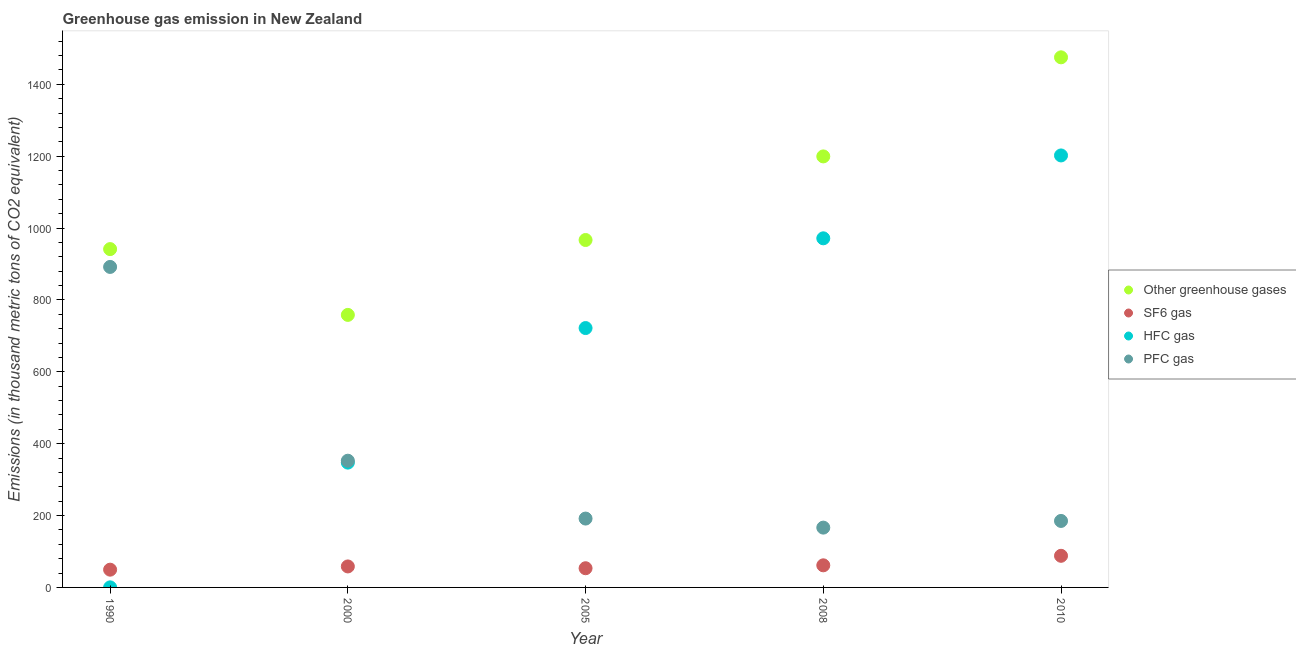How many different coloured dotlines are there?
Provide a succinct answer. 4. What is the emission of hfc gas in 2000?
Keep it short and to the point. 347.3. Across all years, what is the maximum emission of hfc gas?
Keep it short and to the point. 1202. Across all years, what is the minimum emission of hfc gas?
Provide a short and direct response. 0.2. What is the total emission of pfc gas in the graph?
Your response must be concise. 1787.4. What is the difference between the emission of sf6 gas in 2000 and that in 2008?
Offer a terse response. -3.1. What is the difference between the emission of hfc gas in 2010 and the emission of greenhouse gases in 2008?
Your answer should be very brief. 2.7. What is the average emission of sf6 gas per year?
Offer a terse response. 62.14. In the year 2005, what is the difference between the emission of greenhouse gases and emission of hfc gas?
Ensure brevity in your answer.  245. What is the ratio of the emission of pfc gas in 2000 to that in 2008?
Provide a succinct answer. 2.12. Is the emission of greenhouse gases in 2008 less than that in 2010?
Provide a short and direct response. Yes. Is the difference between the emission of greenhouse gases in 2008 and 2010 greater than the difference between the emission of pfc gas in 2008 and 2010?
Give a very brief answer. No. What is the difference between the highest and the lowest emission of pfc gas?
Offer a very short reply. 725.4. Is it the case that in every year, the sum of the emission of pfc gas and emission of sf6 gas is greater than the sum of emission of greenhouse gases and emission of hfc gas?
Provide a succinct answer. No. Is the emission of hfc gas strictly less than the emission of greenhouse gases over the years?
Give a very brief answer. Yes. How many years are there in the graph?
Give a very brief answer. 5. What is the difference between two consecutive major ticks on the Y-axis?
Provide a succinct answer. 200. Does the graph contain grids?
Keep it short and to the point. No. How are the legend labels stacked?
Ensure brevity in your answer.  Vertical. What is the title of the graph?
Give a very brief answer. Greenhouse gas emission in New Zealand. Does "Secondary general" appear as one of the legend labels in the graph?
Make the answer very short. No. What is the label or title of the Y-axis?
Offer a terse response. Emissions (in thousand metric tons of CO2 equivalent). What is the Emissions (in thousand metric tons of CO2 equivalent) of Other greenhouse gases in 1990?
Provide a succinct answer. 941.4. What is the Emissions (in thousand metric tons of CO2 equivalent) of SF6 gas in 1990?
Give a very brief answer. 49.4. What is the Emissions (in thousand metric tons of CO2 equivalent) of PFC gas in 1990?
Provide a succinct answer. 891.8. What is the Emissions (in thousand metric tons of CO2 equivalent) in Other greenhouse gases in 2000?
Your answer should be compact. 758.3. What is the Emissions (in thousand metric tons of CO2 equivalent) in SF6 gas in 2000?
Give a very brief answer. 58.4. What is the Emissions (in thousand metric tons of CO2 equivalent) of HFC gas in 2000?
Ensure brevity in your answer.  347.3. What is the Emissions (in thousand metric tons of CO2 equivalent) in PFC gas in 2000?
Ensure brevity in your answer.  352.6. What is the Emissions (in thousand metric tons of CO2 equivalent) in Other greenhouse gases in 2005?
Your answer should be very brief. 966.7. What is the Emissions (in thousand metric tons of CO2 equivalent) of SF6 gas in 2005?
Offer a terse response. 53.4. What is the Emissions (in thousand metric tons of CO2 equivalent) in HFC gas in 2005?
Provide a succinct answer. 721.7. What is the Emissions (in thousand metric tons of CO2 equivalent) of PFC gas in 2005?
Offer a very short reply. 191.6. What is the Emissions (in thousand metric tons of CO2 equivalent) in Other greenhouse gases in 2008?
Make the answer very short. 1199.3. What is the Emissions (in thousand metric tons of CO2 equivalent) of SF6 gas in 2008?
Offer a terse response. 61.5. What is the Emissions (in thousand metric tons of CO2 equivalent) of HFC gas in 2008?
Provide a short and direct response. 971.4. What is the Emissions (in thousand metric tons of CO2 equivalent) in PFC gas in 2008?
Ensure brevity in your answer.  166.4. What is the Emissions (in thousand metric tons of CO2 equivalent) in Other greenhouse gases in 2010?
Provide a succinct answer. 1475. What is the Emissions (in thousand metric tons of CO2 equivalent) in SF6 gas in 2010?
Give a very brief answer. 88. What is the Emissions (in thousand metric tons of CO2 equivalent) in HFC gas in 2010?
Keep it short and to the point. 1202. What is the Emissions (in thousand metric tons of CO2 equivalent) in PFC gas in 2010?
Provide a short and direct response. 185. Across all years, what is the maximum Emissions (in thousand metric tons of CO2 equivalent) of Other greenhouse gases?
Provide a short and direct response. 1475. Across all years, what is the maximum Emissions (in thousand metric tons of CO2 equivalent) of SF6 gas?
Keep it short and to the point. 88. Across all years, what is the maximum Emissions (in thousand metric tons of CO2 equivalent) of HFC gas?
Provide a succinct answer. 1202. Across all years, what is the maximum Emissions (in thousand metric tons of CO2 equivalent) of PFC gas?
Your answer should be very brief. 891.8. Across all years, what is the minimum Emissions (in thousand metric tons of CO2 equivalent) in Other greenhouse gases?
Offer a terse response. 758.3. Across all years, what is the minimum Emissions (in thousand metric tons of CO2 equivalent) of SF6 gas?
Give a very brief answer. 49.4. Across all years, what is the minimum Emissions (in thousand metric tons of CO2 equivalent) in PFC gas?
Offer a very short reply. 166.4. What is the total Emissions (in thousand metric tons of CO2 equivalent) in Other greenhouse gases in the graph?
Your response must be concise. 5340.7. What is the total Emissions (in thousand metric tons of CO2 equivalent) in SF6 gas in the graph?
Your answer should be compact. 310.7. What is the total Emissions (in thousand metric tons of CO2 equivalent) of HFC gas in the graph?
Offer a very short reply. 3242.6. What is the total Emissions (in thousand metric tons of CO2 equivalent) of PFC gas in the graph?
Provide a succinct answer. 1787.4. What is the difference between the Emissions (in thousand metric tons of CO2 equivalent) in Other greenhouse gases in 1990 and that in 2000?
Your response must be concise. 183.1. What is the difference between the Emissions (in thousand metric tons of CO2 equivalent) of SF6 gas in 1990 and that in 2000?
Ensure brevity in your answer.  -9. What is the difference between the Emissions (in thousand metric tons of CO2 equivalent) in HFC gas in 1990 and that in 2000?
Your answer should be compact. -347.1. What is the difference between the Emissions (in thousand metric tons of CO2 equivalent) of PFC gas in 1990 and that in 2000?
Make the answer very short. 539.2. What is the difference between the Emissions (in thousand metric tons of CO2 equivalent) in Other greenhouse gases in 1990 and that in 2005?
Give a very brief answer. -25.3. What is the difference between the Emissions (in thousand metric tons of CO2 equivalent) of HFC gas in 1990 and that in 2005?
Offer a very short reply. -721.5. What is the difference between the Emissions (in thousand metric tons of CO2 equivalent) of PFC gas in 1990 and that in 2005?
Give a very brief answer. 700.2. What is the difference between the Emissions (in thousand metric tons of CO2 equivalent) of Other greenhouse gases in 1990 and that in 2008?
Give a very brief answer. -257.9. What is the difference between the Emissions (in thousand metric tons of CO2 equivalent) in SF6 gas in 1990 and that in 2008?
Ensure brevity in your answer.  -12.1. What is the difference between the Emissions (in thousand metric tons of CO2 equivalent) of HFC gas in 1990 and that in 2008?
Provide a succinct answer. -971.2. What is the difference between the Emissions (in thousand metric tons of CO2 equivalent) of PFC gas in 1990 and that in 2008?
Give a very brief answer. 725.4. What is the difference between the Emissions (in thousand metric tons of CO2 equivalent) in Other greenhouse gases in 1990 and that in 2010?
Provide a short and direct response. -533.6. What is the difference between the Emissions (in thousand metric tons of CO2 equivalent) in SF6 gas in 1990 and that in 2010?
Your answer should be compact. -38.6. What is the difference between the Emissions (in thousand metric tons of CO2 equivalent) in HFC gas in 1990 and that in 2010?
Provide a short and direct response. -1201.8. What is the difference between the Emissions (in thousand metric tons of CO2 equivalent) in PFC gas in 1990 and that in 2010?
Keep it short and to the point. 706.8. What is the difference between the Emissions (in thousand metric tons of CO2 equivalent) of Other greenhouse gases in 2000 and that in 2005?
Offer a very short reply. -208.4. What is the difference between the Emissions (in thousand metric tons of CO2 equivalent) in HFC gas in 2000 and that in 2005?
Provide a short and direct response. -374.4. What is the difference between the Emissions (in thousand metric tons of CO2 equivalent) of PFC gas in 2000 and that in 2005?
Keep it short and to the point. 161. What is the difference between the Emissions (in thousand metric tons of CO2 equivalent) in Other greenhouse gases in 2000 and that in 2008?
Make the answer very short. -441. What is the difference between the Emissions (in thousand metric tons of CO2 equivalent) in HFC gas in 2000 and that in 2008?
Provide a short and direct response. -624.1. What is the difference between the Emissions (in thousand metric tons of CO2 equivalent) of PFC gas in 2000 and that in 2008?
Keep it short and to the point. 186.2. What is the difference between the Emissions (in thousand metric tons of CO2 equivalent) in Other greenhouse gases in 2000 and that in 2010?
Offer a terse response. -716.7. What is the difference between the Emissions (in thousand metric tons of CO2 equivalent) in SF6 gas in 2000 and that in 2010?
Provide a short and direct response. -29.6. What is the difference between the Emissions (in thousand metric tons of CO2 equivalent) of HFC gas in 2000 and that in 2010?
Your response must be concise. -854.7. What is the difference between the Emissions (in thousand metric tons of CO2 equivalent) in PFC gas in 2000 and that in 2010?
Provide a short and direct response. 167.6. What is the difference between the Emissions (in thousand metric tons of CO2 equivalent) of Other greenhouse gases in 2005 and that in 2008?
Make the answer very short. -232.6. What is the difference between the Emissions (in thousand metric tons of CO2 equivalent) of HFC gas in 2005 and that in 2008?
Provide a short and direct response. -249.7. What is the difference between the Emissions (in thousand metric tons of CO2 equivalent) in PFC gas in 2005 and that in 2008?
Provide a short and direct response. 25.2. What is the difference between the Emissions (in thousand metric tons of CO2 equivalent) of Other greenhouse gases in 2005 and that in 2010?
Offer a very short reply. -508.3. What is the difference between the Emissions (in thousand metric tons of CO2 equivalent) of SF6 gas in 2005 and that in 2010?
Your answer should be compact. -34.6. What is the difference between the Emissions (in thousand metric tons of CO2 equivalent) of HFC gas in 2005 and that in 2010?
Your response must be concise. -480.3. What is the difference between the Emissions (in thousand metric tons of CO2 equivalent) of Other greenhouse gases in 2008 and that in 2010?
Offer a very short reply. -275.7. What is the difference between the Emissions (in thousand metric tons of CO2 equivalent) of SF6 gas in 2008 and that in 2010?
Offer a very short reply. -26.5. What is the difference between the Emissions (in thousand metric tons of CO2 equivalent) of HFC gas in 2008 and that in 2010?
Offer a terse response. -230.6. What is the difference between the Emissions (in thousand metric tons of CO2 equivalent) in PFC gas in 2008 and that in 2010?
Give a very brief answer. -18.6. What is the difference between the Emissions (in thousand metric tons of CO2 equivalent) of Other greenhouse gases in 1990 and the Emissions (in thousand metric tons of CO2 equivalent) of SF6 gas in 2000?
Offer a terse response. 883. What is the difference between the Emissions (in thousand metric tons of CO2 equivalent) in Other greenhouse gases in 1990 and the Emissions (in thousand metric tons of CO2 equivalent) in HFC gas in 2000?
Ensure brevity in your answer.  594.1. What is the difference between the Emissions (in thousand metric tons of CO2 equivalent) in Other greenhouse gases in 1990 and the Emissions (in thousand metric tons of CO2 equivalent) in PFC gas in 2000?
Ensure brevity in your answer.  588.8. What is the difference between the Emissions (in thousand metric tons of CO2 equivalent) of SF6 gas in 1990 and the Emissions (in thousand metric tons of CO2 equivalent) of HFC gas in 2000?
Offer a very short reply. -297.9. What is the difference between the Emissions (in thousand metric tons of CO2 equivalent) in SF6 gas in 1990 and the Emissions (in thousand metric tons of CO2 equivalent) in PFC gas in 2000?
Make the answer very short. -303.2. What is the difference between the Emissions (in thousand metric tons of CO2 equivalent) in HFC gas in 1990 and the Emissions (in thousand metric tons of CO2 equivalent) in PFC gas in 2000?
Ensure brevity in your answer.  -352.4. What is the difference between the Emissions (in thousand metric tons of CO2 equivalent) in Other greenhouse gases in 1990 and the Emissions (in thousand metric tons of CO2 equivalent) in SF6 gas in 2005?
Keep it short and to the point. 888. What is the difference between the Emissions (in thousand metric tons of CO2 equivalent) of Other greenhouse gases in 1990 and the Emissions (in thousand metric tons of CO2 equivalent) of HFC gas in 2005?
Your response must be concise. 219.7. What is the difference between the Emissions (in thousand metric tons of CO2 equivalent) of Other greenhouse gases in 1990 and the Emissions (in thousand metric tons of CO2 equivalent) of PFC gas in 2005?
Your answer should be compact. 749.8. What is the difference between the Emissions (in thousand metric tons of CO2 equivalent) of SF6 gas in 1990 and the Emissions (in thousand metric tons of CO2 equivalent) of HFC gas in 2005?
Offer a very short reply. -672.3. What is the difference between the Emissions (in thousand metric tons of CO2 equivalent) in SF6 gas in 1990 and the Emissions (in thousand metric tons of CO2 equivalent) in PFC gas in 2005?
Your answer should be very brief. -142.2. What is the difference between the Emissions (in thousand metric tons of CO2 equivalent) in HFC gas in 1990 and the Emissions (in thousand metric tons of CO2 equivalent) in PFC gas in 2005?
Keep it short and to the point. -191.4. What is the difference between the Emissions (in thousand metric tons of CO2 equivalent) in Other greenhouse gases in 1990 and the Emissions (in thousand metric tons of CO2 equivalent) in SF6 gas in 2008?
Your answer should be compact. 879.9. What is the difference between the Emissions (in thousand metric tons of CO2 equivalent) of Other greenhouse gases in 1990 and the Emissions (in thousand metric tons of CO2 equivalent) of PFC gas in 2008?
Offer a very short reply. 775. What is the difference between the Emissions (in thousand metric tons of CO2 equivalent) of SF6 gas in 1990 and the Emissions (in thousand metric tons of CO2 equivalent) of HFC gas in 2008?
Offer a terse response. -922. What is the difference between the Emissions (in thousand metric tons of CO2 equivalent) in SF6 gas in 1990 and the Emissions (in thousand metric tons of CO2 equivalent) in PFC gas in 2008?
Your answer should be compact. -117. What is the difference between the Emissions (in thousand metric tons of CO2 equivalent) in HFC gas in 1990 and the Emissions (in thousand metric tons of CO2 equivalent) in PFC gas in 2008?
Offer a very short reply. -166.2. What is the difference between the Emissions (in thousand metric tons of CO2 equivalent) in Other greenhouse gases in 1990 and the Emissions (in thousand metric tons of CO2 equivalent) in SF6 gas in 2010?
Provide a succinct answer. 853.4. What is the difference between the Emissions (in thousand metric tons of CO2 equivalent) in Other greenhouse gases in 1990 and the Emissions (in thousand metric tons of CO2 equivalent) in HFC gas in 2010?
Provide a succinct answer. -260.6. What is the difference between the Emissions (in thousand metric tons of CO2 equivalent) in Other greenhouse gases in 1990 and the Emissions (in thousand metric tons of CO2 equivalent) in PFC gas in 2010?
Make the answer very short. 756.4. What is the difference between the Emissions (in thousand metric tons of CO2 equivalent) of SF6 gas in 1990 and the Emissions (in thousand metric tons of CO2 equivalent) of HFC gas in 2010?
Keep it short and to the point. -1152.6. What is the difference between the Emissions (in thousand metric tons of CO2 equivalent) in SF6 gas in 1990 and the Emissions (in thousand metric tons of CO2 equivalent) in PFC gas in 2010?
Provide a succinct answer. -135.6. What is the difference between the Emissions (in thousand metric tons of CO2 equivalent) of HFC gas in 1990 and the Emissions (in thousand metric tons of CO2 equivalent) of PFC gas in 2010?
Give a very brief answer. -184.8. What is the difference between the Emissions (in thousand metric tons of CO2 equivalent) in Other greenhouse gases in 2000 and the Emissions (in thousand metric tons of CO2 equivalent) in SF6 gas in 2005?
Give a very brief answer. 704.9. What is the difference between the Emissions (in thousand metric tons of CO2 equivalent) of Other greenhouse gases in 2000 and the Emissions (in thousand metric tons of CO2 equivalent) of HFC gas in 2005?
Make the answer very short. 36.6. What is the difference between the Emissions (in thousand metric tons of CO2 equivalent) in Other greenhouse gases in 2000 and the Emissions (in thousand metric tons of CO2 equivalent) in PFC gas in 2005?
Your response must be concise. 566.7. What is the difference between the Emissions (in thousand metric tons of CO2 equivalent) in SF6 gas in 2000 and the Emissions (in thousand metric tons of CO2 equivalent) in HFC gas in 2005?
Provide a short and direct response. -663.3. What is the difference between the Emissions (in thousand metric tons of CO2 equivalent) of SF6 gas in 2000 and the Emissions (in thousand metric tons of CO2 equivalent) of PFC gas in 2005?
Keep it short and to the point. -133.2. What is the difference between the Emissions (in thousand metric tons of CO2 equivalent) in HFC gas in 2000 and the Emissions (in thousand metric tons of CO2 equivalent) in PFC gas in 2005?
Your answer should be compact. 155.7. What is the difference between the Emissions (in thousand metric tons of CO2 equivalent) in Other greenhouse gases in 2000 and the Emissions (in thousand metric tons of CO2 equivalent) in SF6 gas in 2008?
Offer a very short reply. 696.8. What is the difference between the Emissions (in thousand metric tons of CO2 equivalent) of Other greenhouse gases in 2000 and the Emissions (in thousand metric tons of CO2 equivalent) of HFC gas in 2008?
Offer a terse response. -213.1. What is the difference between the Emissions (in thousand metric tons of CO2 equivalent) of Other greenhouse gases in 2000 and the Emissions (in thousand metric tons of CO2 equivalent) of PFC gas in 2008?
Give a very brief answer. 591.9. What is the difference between the Emissions (in thousand metric tons of CO2 equivalent) in SF6 gas in 2000 and the Emissions (in thousand metric tons of CO2 equivalent) in HFC gas in 2008?
Make the answer very short. -913. What is the difference between the Emissions (in thousand metric tons of CO2 equivalent) in SF6 gas in 2000 and the Emissions (in thousand metric tons of CO2 equivalent) in PFC gas in 2008?
Provide a succinct answer. -108. What is the difference between the Emissions (in thousand metric tons of CO2 equivalent) in HFC gas in 2000 and the Emissions (in thousand metric tons of CO2 equivalent) in PFC gas in 2008?
Offer a very short reply. 180.9. What is the difference between the Emissions (in thousand metric tons of CO2 equivalent) in Other greenhouse gases in 2000 and the Emissions (in thousand metric tons of CO2 equivalent) in SF6 gas in 2010?
Provide a short and direct response. 670.3. What is the difference between the Emissions (in thousand metric tons of CO2 equivalent) of Other greenhouse gases in 2000 and the Emissions (in thousand metric tons of CO2 equivalent) of HFC gas in 2010?
Your answer should be compact. -443.7. What is the difference between the Emissions (in thousand metric tons of CO2 equivalent) in Other greenhouse gases in 2000 and the Emissions (in thousand metric tons of CO2 equivalent) in PFC gas in 2010?
Give a very brief answer. 573.3. What is the difference between the Emissions (in thousand metric tons of CO2 equivalent) in SF6 gas in 2000 and the Emissions (in thousand metric tons of CO2 equivalent) in HFC gas in 2010?
Give a very brief answer. -1143.6. What is the difference between the Emissions (in thousand metric tons of CO2 equivalent) in SF6 gas in 2000 and the Emissions (in thousand metric tons of CO2 equivalent) in PFC gas in 2010?
Give a very brief answer. -126.6. What is the difference between the Emissions (in thousand metric tons of CO2 equivalent) in HFC gas in 2000 and the Emissions (in thousand metric tons of CO2 equivalent) in PFC gas in 2010?
Your answer should be compact. 162.3. What is the difference between the Emissions (in thousand metric tons of CO2 equivalent) of Other greenhouse gases in 2005 and the Emissions (in thousand metric tons of CO2 equivalent) of SF6 gas in 2008?
Offer a very short reply. 905.2. What is the difference between the Emissions (in thousand metric tons of CO2 equivalent) of Other greenhouse gases in 2005 and the Emissions (in thousand metric tons of CO2 equivalent) of HFC gas in 2008?
Offer a very short reply. -4.7. What is the difference between the Emissions (in thousand metric tons of CO2 equivalent) of Other greenhouse gases in 2005 and the Emissions (in thousand metric tons of CO2 equivalent) of PFC gas in 2008?
Provide a succinct answer. 800.3. What is the difference between the Emissions (in thousand metric tons of CO2 equivalent) in SF6 gas in 2005 and the Emissions (in thousand metric tons of CO2 equivalent) in HFC gas in 2008?
Your answer should be very brief. -918. What is the difference between the Emissions (in thousand metric tons of CO2 equivalent) of SF6 gas in 2005 and the Emissions (in thousand metric tons of CO2 equivalent) of PFC gas in 2008?
Your answer should be compact. -113. What is the difference between the Emissions (in thousand metric tons of CO2 equivalent) of HFC gas in 2005 and the Emissions (in thousand metric tons of CO2 equivalent) of PFC gas in 2008?
Your response must be concise. 555.3. What is the difference between the Emissions (in thousand metric tons of CO2 equivalent) in Other greenhouse gases in 2005 and the Emissions (in thousand metric tons of CO2 equivalent) in SF6 gas in 2010?
Your answer should be very brief. 878.7. What is the difference between the Emissions (in thousand metric tons of CO2 equivalent) in Other greenhouse gases in 2005 and the Emissions (in thousand metric tons of CO2 equivalent) in HFC gas in 2010?
Offer a very short reply. -235.3. What is the difference between the Emissions (in thousand metric tons of CO2 equivalent) of Other greenhouse gases in 2005 and the Emissions (in thousand metric tons of CO2 equivalent) of PFC gas in 2010?
Provide a short and direct response. 781.7. What is the difference between the Emissions (in thousand metric tons of CO2 equivalent) in SF6 gas in 2005 and the Emissions (in thousand metric tons of CO2 equivalent) in HFC gas in 2010?
Your answer should be very brief. -1148.6. What is the difference between the Emissions (in thousand metric tons of CO2 equivalent) of SF6 gas in 2005 and the Emissions (in thousand metric tons of CO2 equivalent) of PFC gas in 2010?
Provide a short and direct response. -131.6. What is the difference between the Emissions (in thousand metric tons of CO2 equivalent) of HFC gas in 2005 and the Emissions (in thousand metric tons of CO2 equivalent) of PFC gas in 2010?
Ensure brevity in your answer.  536.7. What is the difference between the Emissions (in thousand metric tons of CO2 equivalent) in Other greenhouse gases in 2008 and the Emissions (in thousand metric tons of CO2 equivalent) in SF6 gas in 2010?
Keep it short and to the point. 1111.3. What is the difference between the Emissions (in thousand metric tons of CO2 equivalent) in Other greenhouse gases in 2008 and the Emissions (in thousand metric tons of CO2 equivalent) in HFC gas in 2010?
Offer a terse response. -2.7. What is the difference between the Emissions (in thousand metric tons of CO2 equivalent) in Other greenhouse gases in 2008 and the Emissions (in thousand metric tons of CO2 equivalent) in PFC gas in 2010?
Ensure brevity in your answer.  1014.3. What is the difference between the Emissions (in thousand metric tons of CO2 equivalent) in SF6 gas in 2008 and the Emissions (in thousand metric tons of CO2 equivalent) in HFC gas in 2010?
Offer a terse response. -1140.5. What is the difference between the Emissions (in thousand metric tons of CO2 equivalent) in SF6 gas in 2008 and the Emissions (in thousand metric tons of CO2 equivalent) in PFC gas in 2010?
Make the answer very short. -123.5. What is the difference between the Emissions (in thousand metric tons of CO2 equivalent) in HFC gas in 2008 and the Emissions (in thousand metric tons of CO2 equivalent) in PFC gas in 2010?
Provide a short and direct response. 786.4. What is the average Emissions (in thousand metric tons of CO2 equivalent) of Other greenhouse gases per year?
Ensure brevity in your answer.  1068.14. What is the average Emissions (in thousand metric tons of CO2 equivalent) in SF6 gas per year?
Give a very brief answer. 62.14. What is the average Emissions (in thousand metric tons of CO2 equivalent) in HFC gas per year?
Offer a very short reply. 648.52. What is the average Emissions (in thousand metric tons of CO2 equivalent) in PFC gas per year?
Your answer should be compact. 357.48. In the year 1990, what is the difference between the Emissions (in thousand metric tons of CO2 equivalent) of Other greenhouse gases and Emissions (in thousand metric tons of CO2 equivalent) of SF6 gas?
Offer a very short reply. 892. In the year 1990, what is the difference between the Emissions (in thousand metric tons of CO2 equivalent) of Other greenhouse gases and Emissions (in thousand metric tons of CO2 equivalent) of HFC gas?
Make the answer very short. 941.2. In the year 1990, what is the difference between the Emissions (in thousand metric tons of CO2 equivalent) of Other greenhouse gases and Emissions (in thousand metric tons of CO2 equivalent) of PFC gas?
Your response must be concise. 49.6. In the year 1990, what is the difference between the Emissions (in thousand metric tons of CO2 equivalent) in SF6 gas and Emissions (in thousand metric tons of CO2 equivalent) in HFC gas?
Offer a terse response. 49.2. In the year 1990, what is the difference between the Emissions (in thousand metric tons of CO2 equivalent) of SF6 gas and Emissions (in thousand metric tons of CO2 equivalent) of PFC gas?
Your answer should be compact. -842.4. In the year 1990, what is the difference between the Emissions (in thousand metric tons of CO2 equivalent) of HFC gas and Emissions (in thousand metric tons of CO2 equivalent) of PFC gas?
Ensure brevity in your answer.  -891.6. In the year 2000, what is the difference between the Emissions (in thousand metric tons of CO2 equivalent) of Other greenhouse gases and Emissions (in thousand metric tons of CO2 equivalent) of SF6 gas?
Give a very brief answer. 699.9. In the year 2000, what is the difference between the Emissions (in thousand metric tons of CO2 equivalent) of Other greenhouse gases and Emissions (in thousand metric tons of CO2 equivalent) of HFC gas?
Make the answer very short. 411. In the year 2000, what is the difference between the Emissions (in thousand metric tons of CO2 equivalent) of Other greenhouse gases and Emissions (in thousand metric tons of CO2 equivalent) of PFC gas?
Provide a succinct answer. 405.7. In the year 2000, what is the difference between the Emissions (in thousand metric tons of CO2 equivalent) in SF6 gas and Emissions (in thousand metric tons of CO2 equivalent) in HFC gas?
Offer a terse response. -288.9. In the year 2000, what is the difference between the Emissions (in thousand metric tons of CO2 equivalent) of SF6 gas and Emissions (in thousand metric tons of CO2 equivalent) of PFC gas?
Your answer should be compact. -294.2. In the year 2005, what is the difference between the Emissions (in thousand metric tons of CO2 equivalent) in Other greenhouse gases and Emissions (in thousand metric tons of CO2 equivalent) in SF6 gas?
Offer a terse response. 913.3. In the year 2005, what is the difference between the Emissions (in thousand metric tons of CO2 equivalent) in Other greenhouse gases and Emissions (in thousand metric tons of CO2 equivalent) in HFC gas?
Offer a very short reply. 245. In the year 2005, what is the difference between the Emissions (in thousand metric tons of CO2 equivalent) in Other greenhouse gases and Emissions (in thousand metric tons of CO2 equivalent) in PFC gas?
Ensure brevity in your answer.  775.1. In the year 2005, what is the difference between the Emissions (in thousand metric tons of CO2 equivalent) of SF6 gas and Emissions (in thousand metric tons of CO2 equivalent) of HFC gas?
Offer a very short reply. -668.3. In the year 2005, what is the difference between the Emissions (in thousand metric tons of CO2 equivalent) in SF6 gas and Emissions (in thousand metric tons of CO2 equivalent) in PFC gas?
Your answer should be compact. -138.2. In the year 2005, what is the difference between the Emissions (in thousand metric tons of CO2 equivalent) of HFC gas and Emissions (in thousand metric tons of CO2 equivalent) of PFC gas?
Make the answer very short. 530.1. In the year 2008, what is the difference between the Emissions (in thousand metric tons of CO2 equivalent) of Other greenhouse gases and Emissions (in thousand metric tons of CO2 equivalent) of SF6 gas?
Ensure brevity in your answer.  1137.8. In the year 2008, what is the difference between the Emissions (in thousand metric tons of CO2 equivalent) in Other greenhouse gases and Emissions (in thousand metric tons of CO2 equivalent) in HFC gas?
Provide a succinct answer. 227.9. In the year 2008, what is the difference between the Emissions (in thousand metric tons of CO2 equivalent) in Other greenhouse gases and Emissions (in thousand metric tons of CO2 equivalent) in PFC gas?
Your response must be concise. 1032.9. In the year 2008, what is the difference between the Emissions (in thousand metric tons of CO2 equivalent) in SF6 gas and Emissions (in thousand metric tons of CO2 equivalent) in HFC gas?
Keep it short and to the point. -909.9. In the year 2008, what is the difference between the Emissions (in thousand metric tons of CO2 equivalent) in SF6 gas and Emissions (in thousand metric tons of CO2 equivalent) in PFC gas?
Offer a very short reply. -104.9. In the year 2008, what is the difference between the Emissions (in thousand metric tons of CO2 equivalent) of HFC gas and Emissions (in thousand metric tons of CO2 equivalent) of PFC gas?
Provide a short and direct response. 805. In the year 2010, what is the difference between the Emissions (in thousand metric tons of CO2 equivalent) in Other greenhouse gases and Emissions (in thousand metric tons of CO2 equivalent) in SF6 gas?
Offer a very short reply. 1387. In the year 2010, what is the difference between the Emissions (in thousand metric tons of CO2 equivalent) in Other greenhouse gases and Emissions (in thousand metric tons of CO2 equivalent) in HFC gas?
Make the answer very short. 273. In the year 2010, what is the difference between the Emissions (in thousand metric tons of CO2 equivalent) in Other greenhouse gases and Emissions (in thousand metric tons of CO2 equivalent) in PFC gas?
Provide a short and direct response. 1290. In the year 2010, what is the difference between the Emissions (in thousand metric tons of CO2 equivalent) in SF6 gas and Emissions (in thousand metric tons of CO2 equivalent) in HFC gas?
Your answer should be very brief. -1114. In the year 2010, what is the difference between the Emissions (in thousand metric tons of CO2 equivalent) in SF6 gas and Emissions (in thousand metric tons of CO2 equivalent) in PFC gas?
Provide a short and direct response. -97. In the year 2010, what is the difference between the Emissions (in thousand metric tons of CO2 equivalent) of HFC gas and Emissions (in thousand metric tons of CO2 equivalent) of PFC gas?
Give a very brief answer. 1017. What is the ratio of the Emissions (in thousand metric tons of CO2 equivalent) in Other greenhouse gases in 1990 to that in 2000?
Give a very brief answer. 1.24. What is the ratio of the Emissions (in thousand metric tons of CO2 equivalent) of SF6 gas in 1990 to that in 2000?
Keep it short and to the point. 0.85. What is the ratio of the Emissions (in thousand metric tons of CO2 equivalent) of HFC gas in 1990 to that in 2000?
Provide a succinct answer. 0. What is the ratio of the Emissions (in thousand metric tons of CO2 equivalent) of PFC gas in 1990 to that in 2000?
Provide a short and direct response. 2.53. What is the ratio of the Emissions (in thousand metric tons of CO2 equivalent) in Other greenhouse gases in 1990 to that in 2005?
Offer a very short reply. 0.97. What is the ratio of the Emissions (in thousand metric tons of CO2 equivalent) in SF6 gas in 1990 to that in 2005?
Offer a terse response. 0.93. What is the ratio of the Emissions (in thousand metric tons of CO2 equivalent) of HFC gas in 1990 to that in 2005?
Provide a succinct answer. 0. What is the ratio of the Emissions (in thousand metric tons of CO2 equivalent) of PFC gas in 1990 to that in 2005?
Offer a very short reply. 4.65. What is the ratio of the Emissions (in thousand metric tons of CO2 equivalent) of Other greenhouse gases in 1990 to that in 2008?
Your answer should be compact. 0.79. What is the ratio of the Emissions (in thousand metric tons of CO2 equivalent) of SF6 gas in 1990 to that in 2008?
Ensure brevity in your answer.  0.8. What is the ratio of the Emissions (in thousand metric tons of CO2 equivalent) in HFC gas in 1990 to that in 2008?
Offer a terse response. 0. What is the ratio of the Emissions (in thousand metric tons of CO2 equivalent) in PFC gas in 1990 to that in 2008?
Offer a very short reply. 5.36. What is the ratio of the Emissions (in thousand metric tons of CO2 equivalent) of Other greenhouse gases in 1990 to that in 2010?
Give a very brief answer. 0.64. What is the ratio of the Emissions (in thousand metric tons of CO2 equivalent) of SF6 gas in 1990 to that in 2010?
Ensure brevity in your answer.  0.56. What is the ratio of the Emissions (in thousand metric tons of CO2 equivalent) in PFC gas in 1990 to that in 2010?
Offer a very short reply. 4.82. What is the ratio of the Emissions (in thousand metric tons of CO2 equivalent) of Other greenhouse gases in 2000 to that in 2005?
Offer a terse response. 0.78. What is the ratio of the Emissions (in thousand metric tons of CO2 equivalent) of SF6 gas in 2000 to that in 2005?
Offer a very short reply. 1.09. What is the ratio of the Emissions (in thousand metric tons of CO2 equivalent) of HFC gas in 2000 to that in 2005?
Ensure brevity in your answer.  0.48. What is the ratio of the Emissions (in thousand metric tons of CO2 equivalent) of PFC gas in 2000 to that in 2005?
Ensure brevity in your answer.  1.84. What is the ratio of the Emissions (in thousand metric tons of CO2 equivalent) in Other greenhouse gases in 2000 to that in 2008?
Provide a short and direct response. 0.63. What is the ratio of the Emissions (in thousand metric tons of CO2 equivalent) of SF6 gas in 2000 to that in 2008?
Your answer should be very brief. 0.95. What is the ratio of the Emissions (in thousand metric tons of CO2 equivalent) in HFC gas in 2000 to that in 2008?
Offer a very short reply. 0.36. What is the ratio of the Emissions (in thousand metric tons of CO2 equivalent) of PFC gas in 2000 to that in 2008?
Offer a terse response. 2.12. What is the ratio of the Emissions (in thousand metric tons of CO2 equivalent) in Other greenhouse gases in 2000 to that in 2010?
Ensure brevity in your answer.  0.51. What is the ratio of the Emissions (in thousand metric tons of CO2 equivalent) of SF6 gas in 2000 to that in 2010?
Keep it short and to the point. 0.66. What is the ratio of the Emissions (in thousand metric tons of CO2 equivalent) of HFC gas in 2000 to that in 2010?
Provide a short and direct response. 0.29. What is the ratio of the Emissions (in thousand metric tons of CO2 equivalent) of PFC gas in 2000 to that in 2010?
Provide a short and direct response. 1.91. What is the ratio of the Emissions (in thousand metric tons of CO2 equivalent) of Other greenhouse gases in 2005 to that in 2008?
Keep it short and to the point. 0.81. What is the ratio of the Emissions (in thousand metric tons of CO2 equivalent) in SF6 gas in 2005 to that in 2008?
Give a very brief answer. 0.87. What is the ratio of the Emissions (in thousand metric tons of CO2 equivalent) in HFC gas in 2005 to that in 2008?
Make the answer very short. 0.74. What is the ratio of the Emissions (in thousand metric tons of CO2 equivalent) in PFC gas in 2005 to that in 2008?
Your answer should be very brief. 1.15. What is the ratio of the Emissions (in thousand metric tons of CO2 equivalent) of Other greenhouse gases in 2005 to that in 2010?
Offer a very short reply. 0.66. What is the ratio of the Emissions (in thousand metric tons of CO2 equivalent) in SF6 gas in 2005 to that in 2010?
Offer a very short reply. 0.61. What is the ratio of the Emissions (in thousand metric tons of CO2 equivalent) in HFC gas in 2005 to that in 2010?
Your answer should be compact. 0.6. What is the ratio of the Emissions (in thousand metric tons of CO2 equivalent) of PFC gas in 2005 to that in 2010?
Ensure brevity in your answer.  1.04. What is the ratio of the Emissions (in thousand metric tons of CO2 equivalent) in Other greenhouse gases in 2008 to that in 2010?
Give a very brief answer. 0.81. What is the ratio of the Emissions (in thousand metric tons of CO2 equivalent) of SF6 gas in 2008 to that in 2010?
Ensure brevity in your answer.  0.7. What is the ratio of the Emissions (in thousand metric tons of CO2 equivalent) of HFC gas in 2008 to that in 2010?
Make the answer very short. 0.81. What is the ratio of the Emissions (in thousand metric tons of CO2 equivalent) of PFC gas in 2008 to that in 2010?
Ensure brevity in your answer.  0.9. What is the difference between the highest and the second highest Emissions (in thousand metric tons of CO2 equivalent) of Other greenhouse gases?
Give a very brief answer. 275.7. What is the difference between the highest and the second highest Emissions (in thousand metric tons of CO2 equivalent) of SF6 gas?
Your answer should be compact. 26.5. What is the difference between the highest and the second highest Emissions (in thousand metric tons of CO2 equivalent) of HFC gas?
Your response must be concise. 230.6. What is the difference between the highest and the second highest Emissions (in thousand metric tons of CO2 equivalent) of PFC gas?
Make the answer very short. 539.2. What is the difference between the highest and the lowest Emissions (in thousand metric tons of CO2 equivalent) of Other greenhouse gases?
Offer a very short reply. 716.7. What is the difference between the highest and the lowest Emissions (in thousand metric tons of CO2 equivalent) of SF6 gas?
Your answer should be compact. 38.6. What is the difference between the highest and the lowest Emissions (in thousand metric tons of CO2 equivalent) of HFC gas?
Make the answer very short. 1201.8. What is the difference between the highest and the lowest Emissions (in thousand metric tons of CO2 equivalent) in PFC gas?
Offer a very short reply. 725.4. 